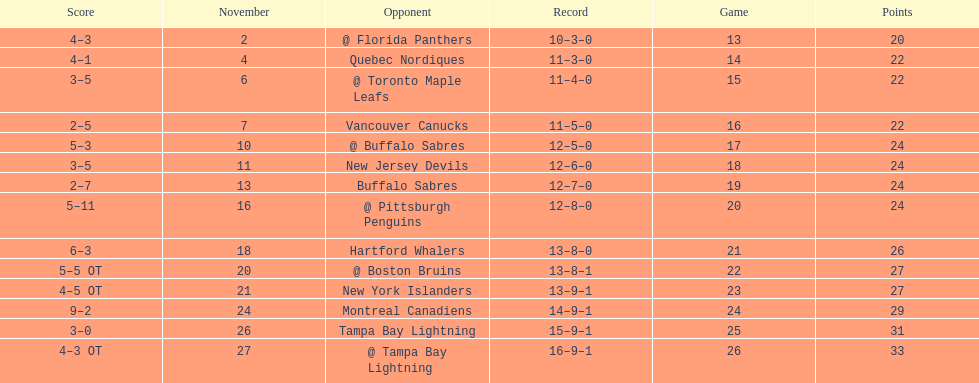Were the new jersey devils in last place according to the chart? No. 